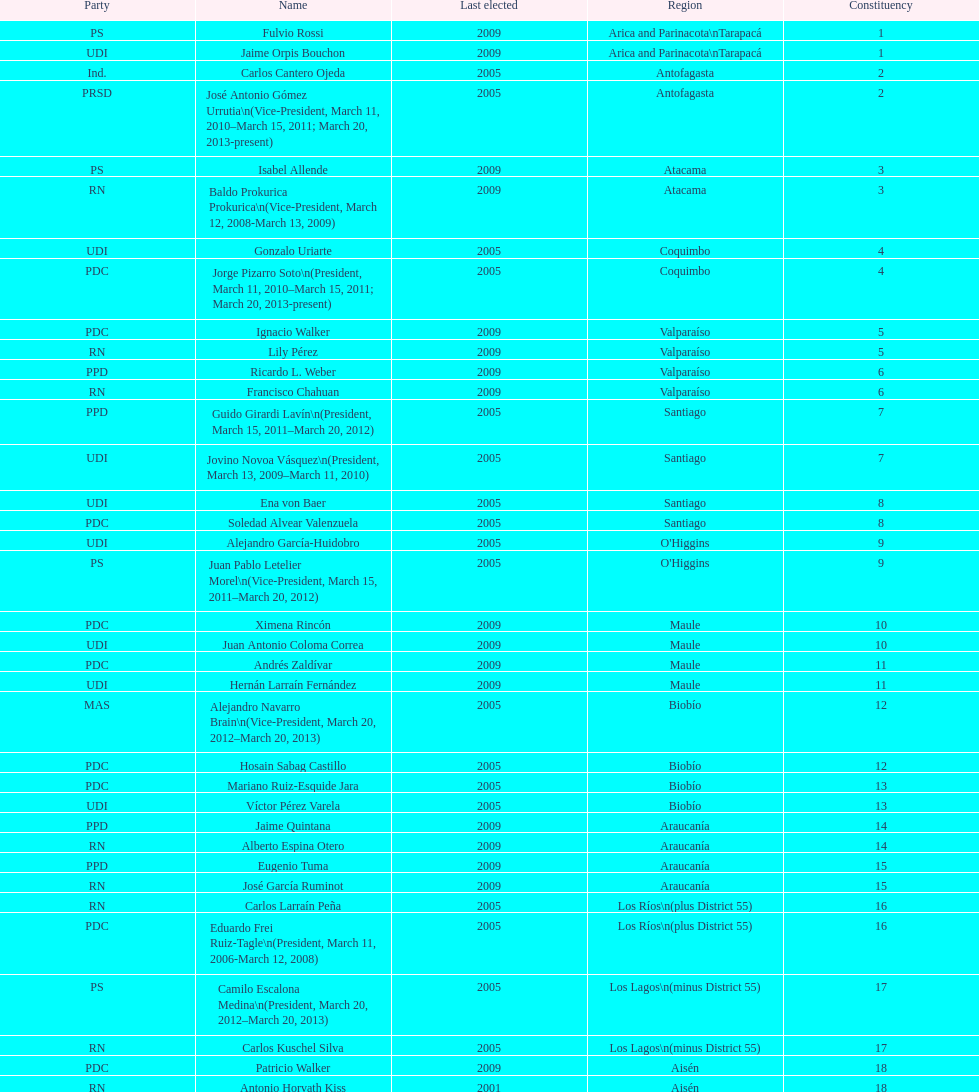When was antonio horvath kiss last elected? 2001. 